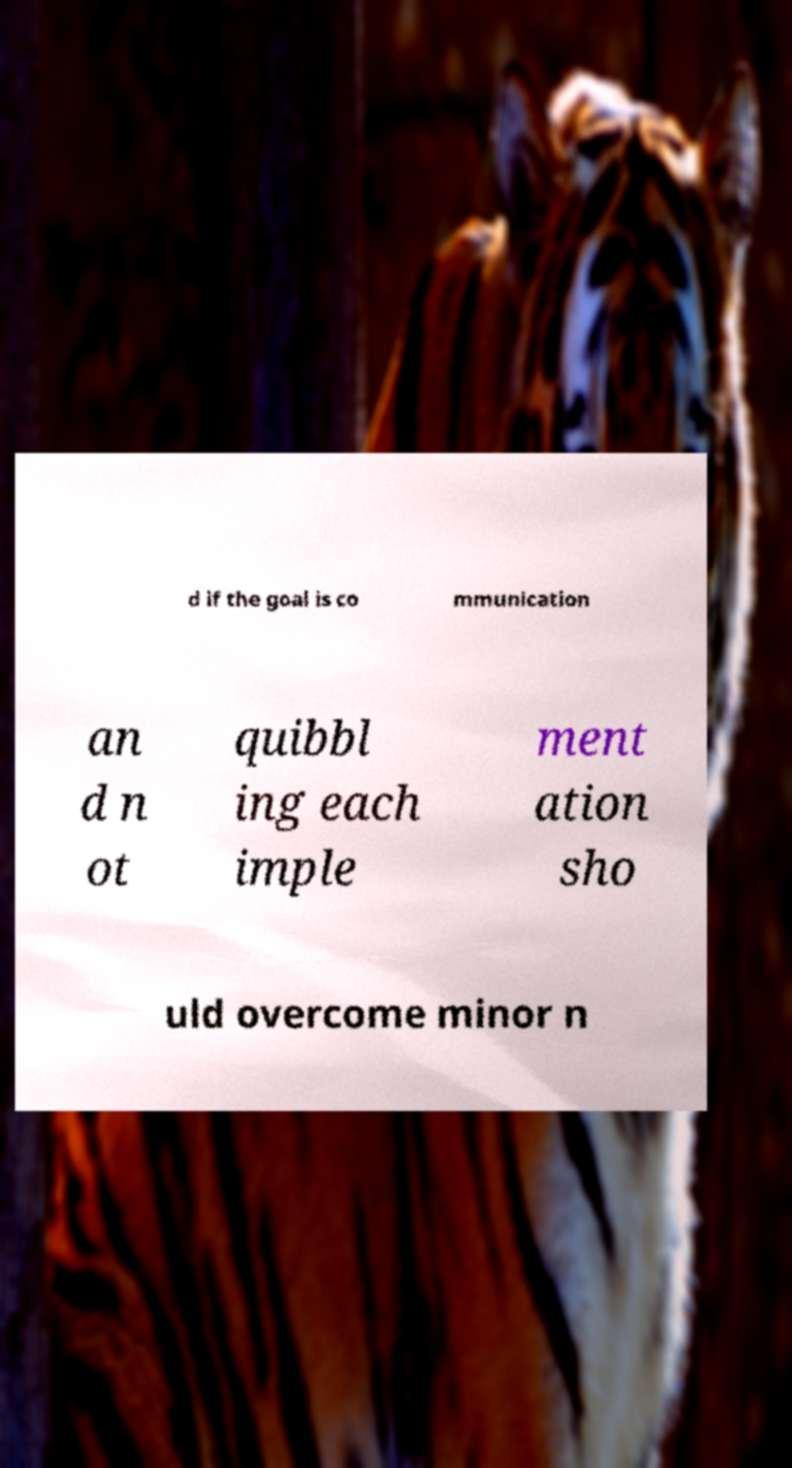For documentation purposes, I need the text within this image transcribed. Could you provide that? d if the goal is co mmunication an d n ot quibbl ing each imple ment ation sho uld overcome minor n 